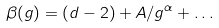Convert formula to latex. <formula><loc_0><loc_0><loc_500><loc_500>\beta ( g ) = ( d - 2 ) + A / g ^ { \alpha } + \dots</formula> 